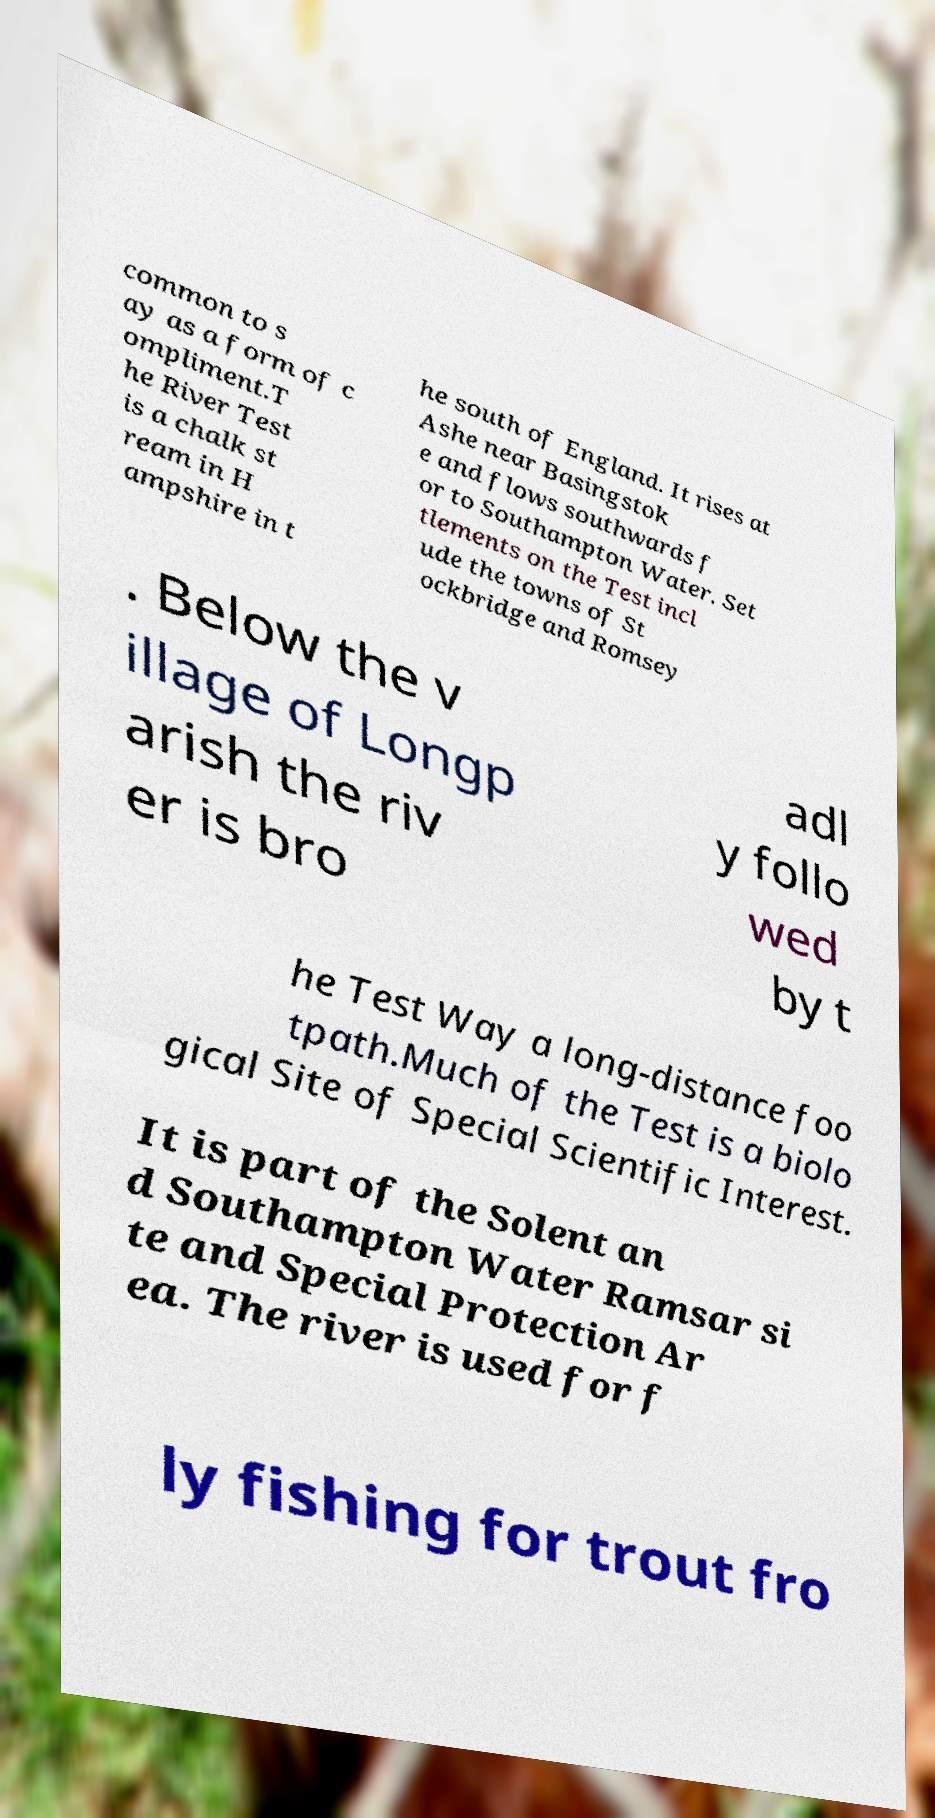For documentation purposes, I need the text within this image transcribed. Could you provide that? common to s ay as a form of c ompliment.T he River Test is a chalk st ream in H ampshire in t he south of England. It rises at Ashe near Basingstok e and flows southwards f or to Southampton Water. Set tlements on the Test incl ude the towns of St ockbridge and Romsey . Below the v illage of Longp arish the riv er is bro adl y follo wed by t he Test Way a long-distance foo tpath.Much of the Test is a biolo gical Site of Special Scientific Interest. It is part of the Solent an d Southampton Water Ramsar si te and Special Protection Ar ea. The river is used for f ly fishing for trout fro 